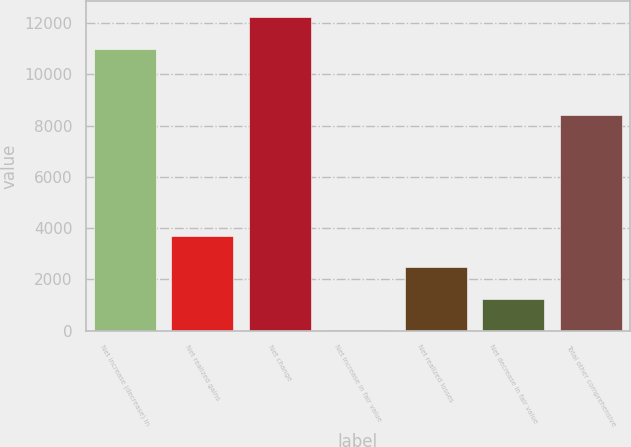Convert chart. <chart><loc_0><loc_0><loc_500><loc_500><bar_chart><fcel>Net increase (decrease) in<fcel>Net realized gains<fcel>Net change<fcel>Net increase in fair value<fcel>Net realized losses<fcel>Net decrease in fair value<fcel>Total other comprehensive<nl><fcel>10989<fcel>3694.4<fcel>12240<fcel>32<fcel>2473.6<fcel>1252.8<fcel>8400<nl></chart> 